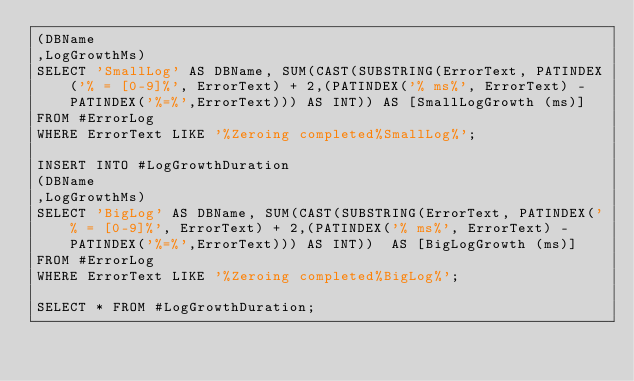<code> <loc_0><loc_0><loc_500><loc_500><_SQL_>(DBName
,LogGrowthMs)
SELECT 'SmallLog' AS DBName, SUM(CAST(SUBSTRING(ErrorText, PATINDEX('% = [0-9]%', ErrorText) + 2,(PATINDEX('% ms%', ErrorText) - PATINDEX('%=%',ErrorText))) AS INT)) AS [SmallLogGrowth (ms)]
FROM #ErrorLog
WHERE ErrorText LIKE '%Zeroing completed%SmallLog%';

INSERT INTO #LogGrowthDuration
(DBName
,LogGrowthMs)
SELECT 'BigLog' AS DBName, SUM(CAST(SUBSTRING(ErrorText, PATINDEX('% = [0-9]%', ErrorText) + 2,(PATINDEX('% ms%', ErrorText) - PATINDEX('%=%',ErrorText))) AS INT))  AS [BigLogGrowth (ms)]
FROM #ErrorLog
WHERE ErrorText LIKE '%Zeroing completed%BigLog%';

SELECT * FROM #LogGrowthDuration;</code> 